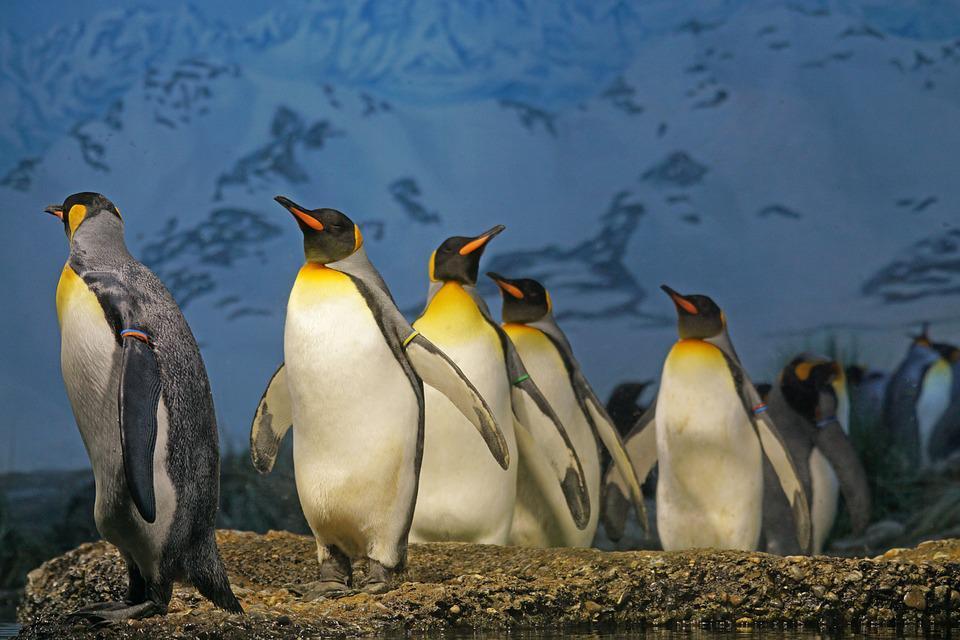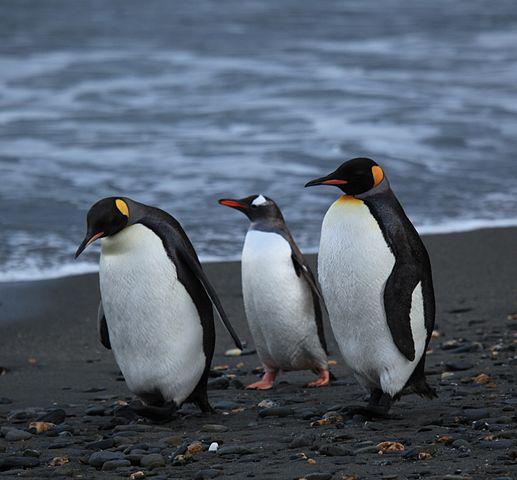The first image is the image on the left, the second image is the image on the right. Given the left and right images, does the statement "The right image has the waters edge visible." hold true? Answer yes or no. Yes. The first image is the image on the left, the second image is the image on the right. Examine the images to the left and right. Is the description "A waddle of penguins is standing in a snowy landscape in one of the images." accurate? Answer yes or no. No. 